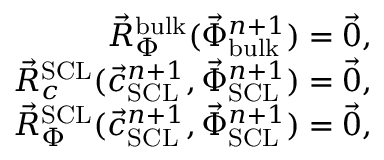Convert formula to latex. <formula><loc_0><loc_0><loc_500><loc_500>\begin{array} { r } { \vec { R } _ { \Phi } ^ { b u l k } ( \vec { \Phi } _ { b u l k } ^ { n + 1 } ) = \vec { 0 } , } \\ { \vec { R } _ { c } ^ { S C L } ( \vec { c } _ { S C L } ^ { n + 1 } , \vec { \Phi } _ { S C L } ^ { n + 1 } ) = \vec { 0 } , } \\ { \vec { R } _ { \Phi } ^ { S C L } ( \vec { c } _ { S C L } ^ { n + 1 } , \vec { \Phi } _ { S C L } ^ { n + 1 } ) = \vec { 0 } , } \end{array}</formula> 